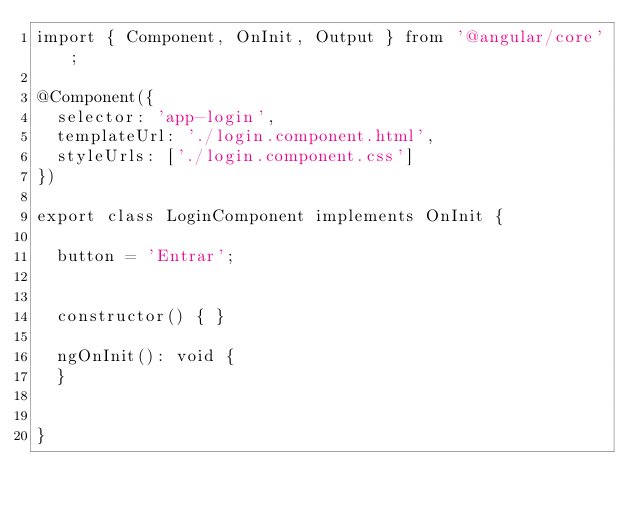Convert code to text. <code><loc_0><loc_0><loc_500><loc_500><_TypeScript_>import { Component, OnInit, Output } from '@angular/core';

@Component({
  selector: 'app-login',
  templateUrl: './login.component.html',
  styleUrls: ['./login.component.css']
})

export class LoginComponent implements OnInit {

  button = 'Entrar';

  
  constructor() { }

  ngOnInit(): void {
  }

  
}
</code> 